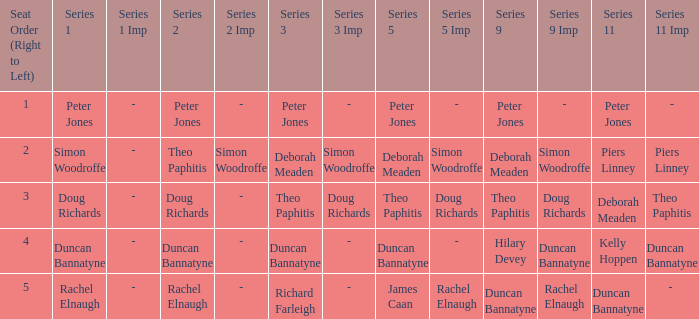How many Seat Orders (Right to Left) have a Series 3 of deborah meaden? 1.0. 